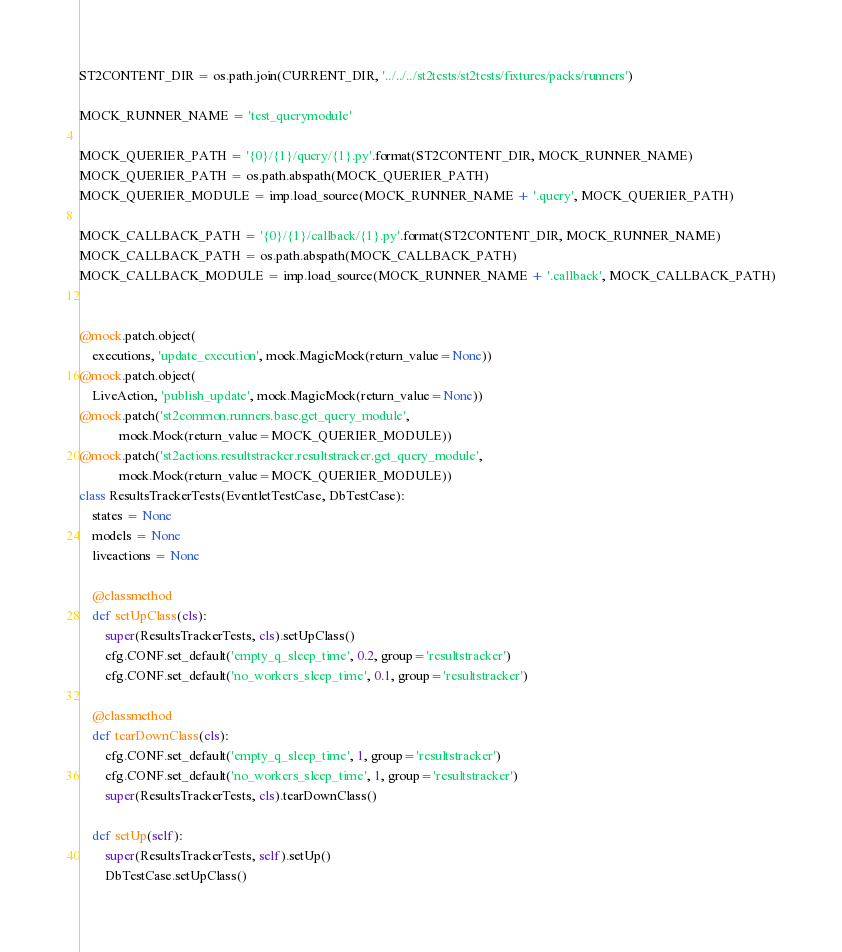<code> <loc_0><loc_0><loc_500><loc_500><_Python_>ST2CONTENT_DIR = os.path.join(CURRENT_DIR, '../../../st2tests/st2tests/fixtures/packs/runners')

MOCK_RUNNER_NAME = 'test_querymodule'

MOCK_QUERIER_PATH = '{0}/{1}/query/{1}.py'.format(ST2CONTENT_DIR, MOCK_RUNNER_NAME)
MOCK_QUERIER_PATH = os.path.abspath(MOCK_QUERIER_PATH)
MOCK_QUERIER_MODULE = imp.load_source(MOCK_RUNNER_NAME + '.query', MOCK_QUERIER_PATH)

MOCK_CALLBACK_PATH = '{0}/{1}/callback/{1}.py'.format(ST2CONTENT_DIR, MOCK_RUNNER_NAME)
MOCK_CALLBACK_PATH = os.path.abspath(MOCK_CALLBACK_PATH)
MOCK_CALLBACK_MODULE = imp.load_source(MOCK_RUNNER_NAME + '.callback', MOCK_CALLBACK_PATH)


@mock.patch.object(
    executions, 'update_execution', mock.MagicMock(return_value=None))
@mock.patch.object(
    LiveAction, 'publish_update', mock.MagicMock(return_value=None))
@mock.patch('st2common.runners.base.get_query_module',
            mock.Mock(return_value=MOCK_QUERIER_MODULE))
@mock.patch('st2actions.resultstracker.resultstracker.get_query_module',
            mock.Mock(return_value=MOCK_QUERIER_MODULE))
class ResultsTrackerTests(EventletTestCase, DbTestCase):
    states = None
    models = None
    liveactions = None

    @classmethod
    def setUpClass(cls):
        super(ResultsTrackerTests, cls).setUpClass()
        cfg.CONF.set_default('empty_q_sleep_time', 0.2, group='resultstracker')
        cfg.CONF.set_default('no_workers_sleep_time', 0.1, group='resultstracker')

    @classmethod
    def tearDownClass(cls):
        cfg.CONF.set_default('empty_q_sleep_time', 1, group='resultstracker')
        cfg.CONF.set_default('no_workers_sleep_time', 1, group='resultstracker')
        super(ResultsTrackerTests, cls).tearDownClass()

    def setUp(self):
        super(ResultsTrackerTests, self).setUp()
        DbTestCase.setUpClass()</code> 